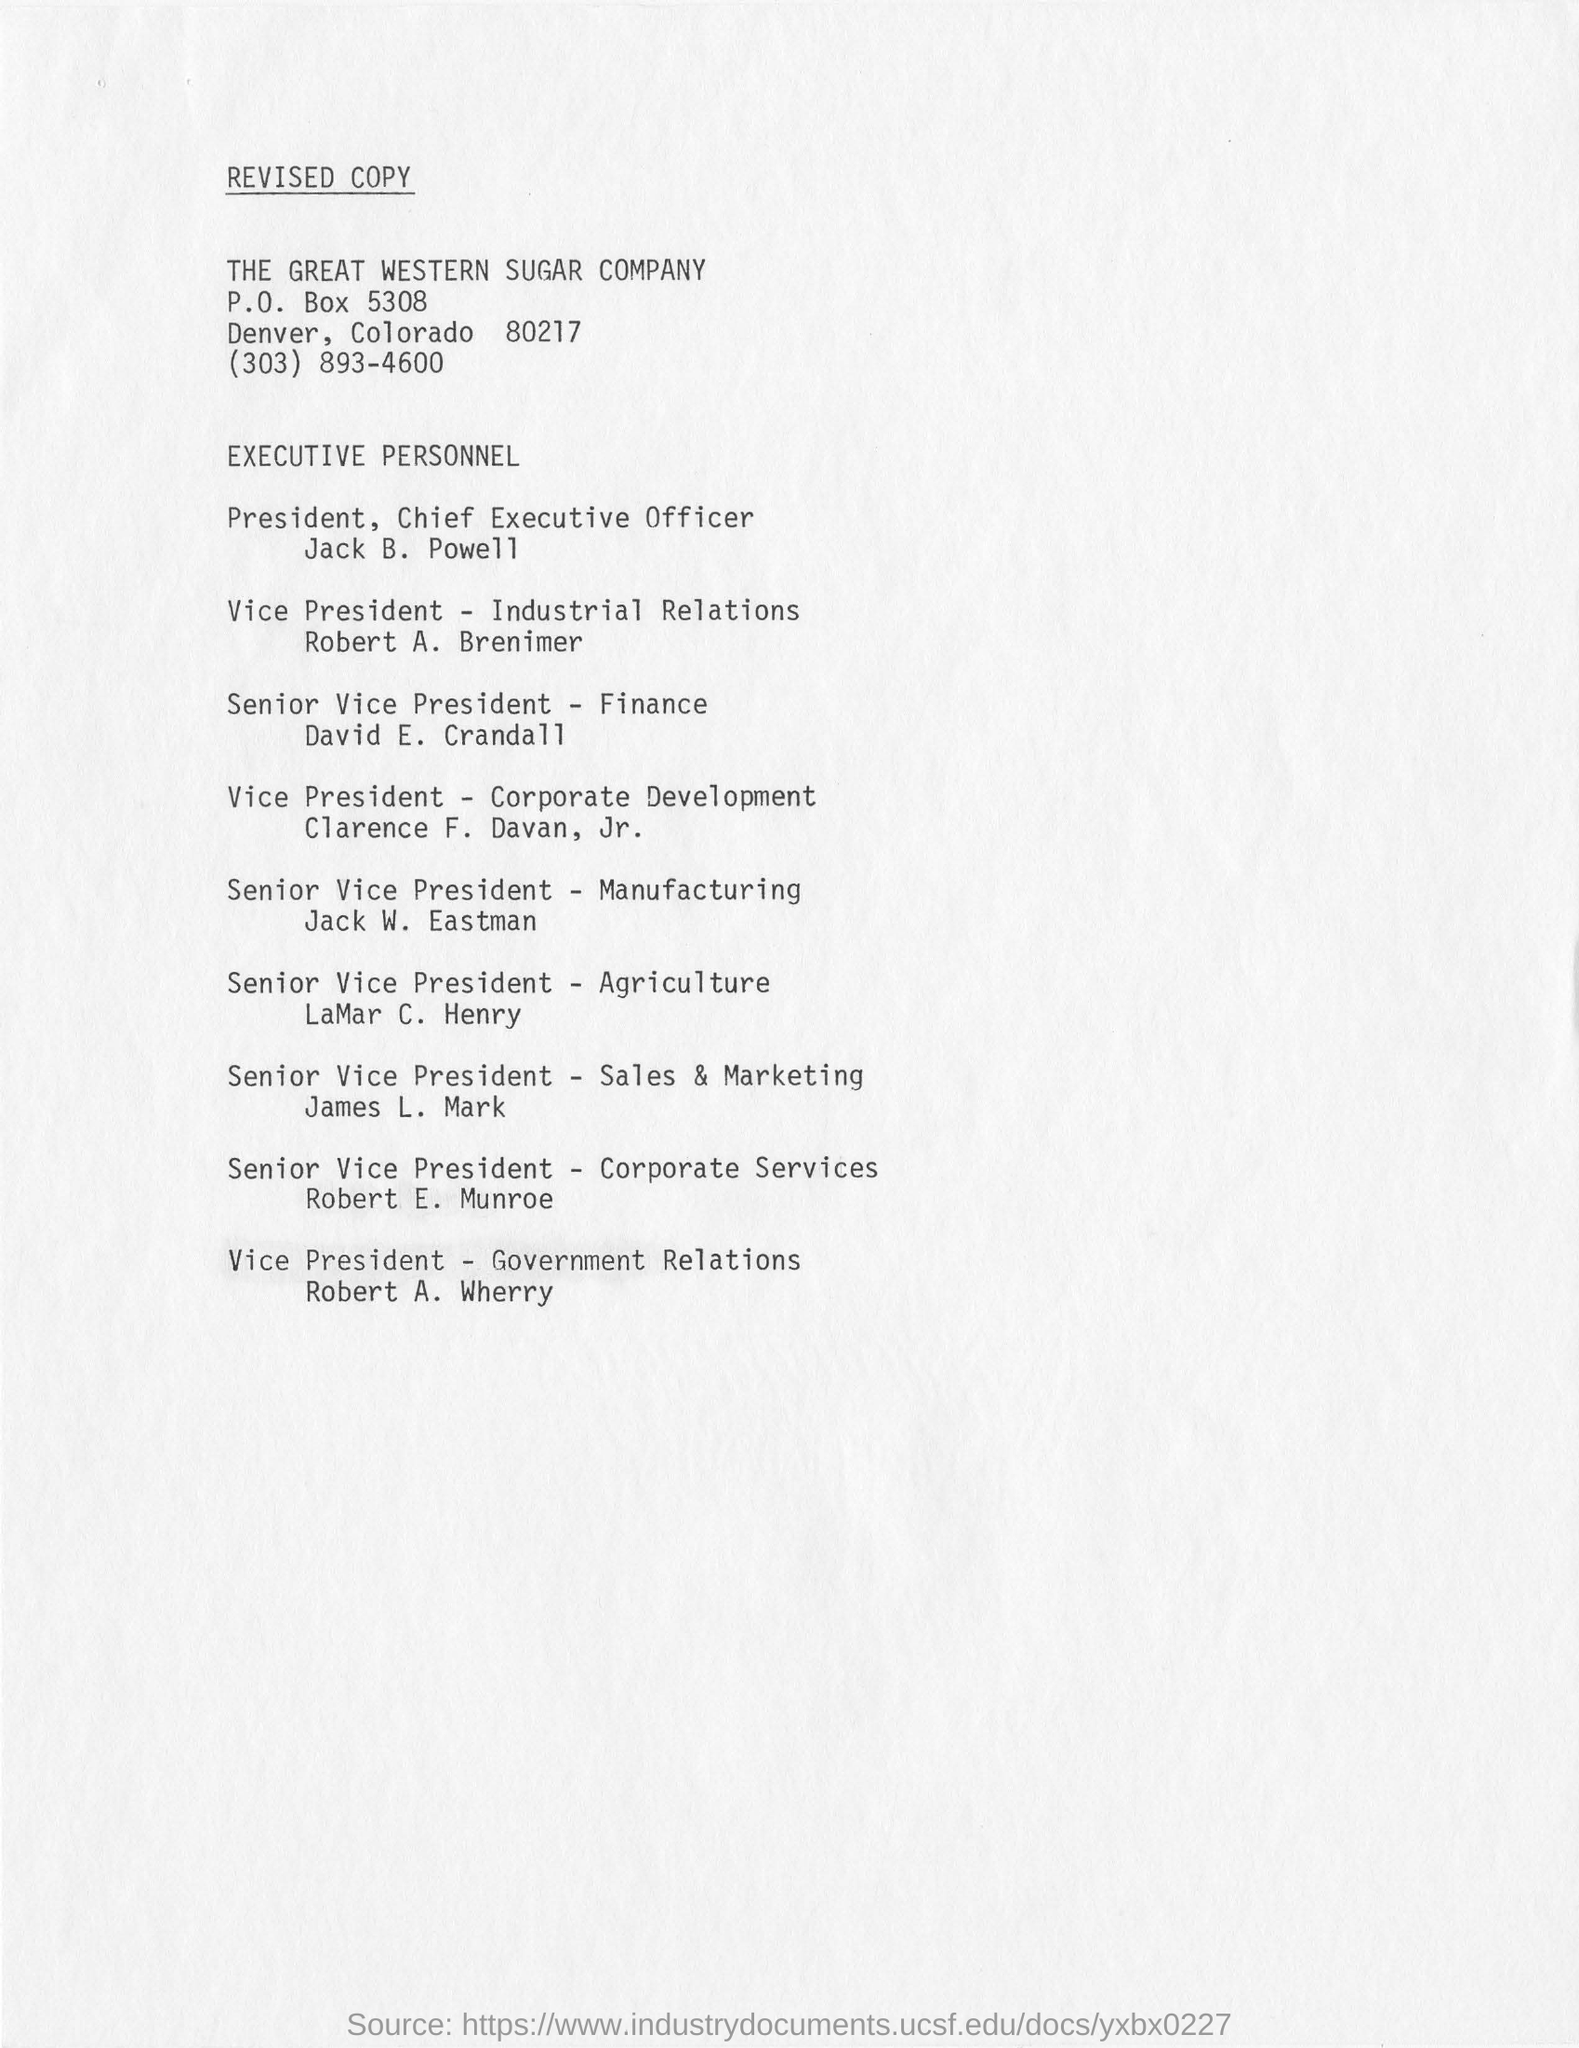Identify some key points in this picture. Robert A. Brenimer is the Vice President of Industrial Relations. Jack W. Eastman, the senior vice president, is affiliated with the manufacturing industry. The individual currently serving as the Senior Vice President of Finance is David E. Crandall. Clarence F. Davan, Jr. is the vice president of corporate development. The individual who holds the position of vice president of government relations is Robert A. Wherry. 